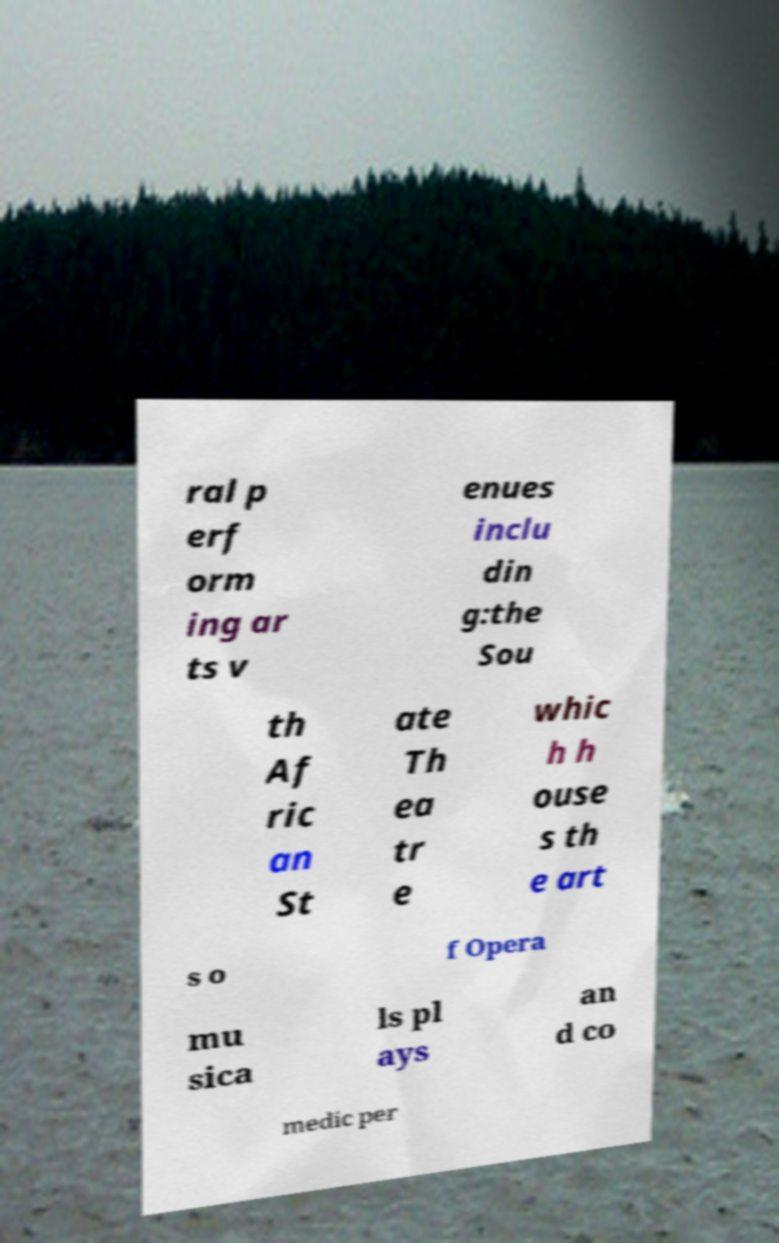Please read and relay the text visible in this image. What does it say? ral p erf orm ing ar ts v enues inclu din g:the Sou th Af ric an St ate Th ea tr e whic h h ouse s th e art s o f Opera mu sica ls pl ays an d co medic per 